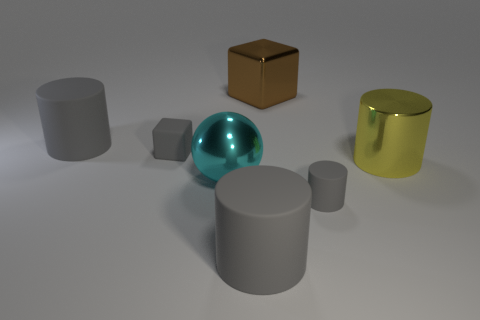How many gray cylinders must be subtracted to get 1 gray cylinders? 2 Subtract all brown blocks. How many gray cylinders are left? 3 Subtract 1 cylinders. How many cylinders are left? 3 Add 2 brown metal things. How many objects exist? 9 Subtract all blocks. How many objects are left? 5 Add 5 large brown objects. How many large brown objects are left? 6 Add 2 matte blocks. How many matte blocks exist? 3 Subtract 0 purple cubes. How many objects are left? 7 Subtract all large brown cubes. Subtract all big yellow objects. How many objects are left? 5 